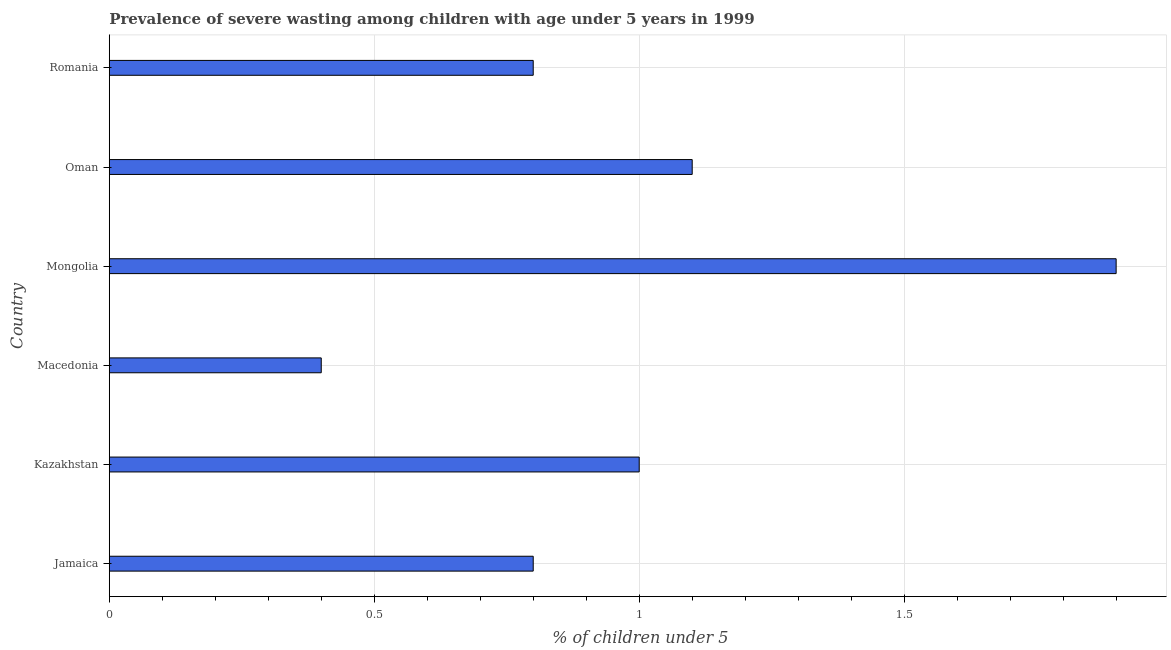Does the graph contain any zero values?
Give a very brief answer. No. What is the title of the graph?
Your response must be concise. Prevalence of severe wasting among children with age under 5 years in 1999. What is the label or title of the X-axis?
Provide a short and direct response.  % of children under 5. Across all countries, what is the maximum prevalence of severe wasting?
Your answer should be very brief. 1.9. Across all countries, what is the minimum prevalence of severe wasting?
Offer a terse response. 0.4. In which country was the prevalence of severe wasting maximum?
Ensure brevity in your answer.  Mongolia. In which country was the prevalence of severe wasting minimum?
Your answer should be compact. Macedonia. What is the sum of the prevalence of severe wasting?
Your answer should be very brief. 6. What is the difference between the prevalence of severe wasting in Jamaica and Mongolia?
Your answer should be very brief. -1.1. What is the median prevalence of severe wasting?
Provide a succinct answer. 0.9. What is the ratio of the prevalence of severe wasting in Jamaica to that in Romania?
Provide a short and direct response. 1. Is the prevalence of severe wasting in Oman less than that in Romania?
Your answer should be very brief. No. Is the difference between the prevalence of severe wasting in Mongolia and Oman greater than the difference between any two countries?
Offer a very short reply. No. What is the difference between the highest and the second highest prevalence of severe wasting?
Offer a terse response. 0.8. In how many countries, is the prevalence of severe wasting greater than the average prevalence of severe wasting taken over all countries?
Offer a terse response. 2. How many bars are there?
Make the answer very short. 6. Are all the bars in the graph horizontal?
Your answer should be very brief. Yes. How many countries are there in the graph?
Offer a very short reply. 6. What is the difference between two consecutive major ticks on the X-axis?
Offer a very short reply. 0.5. Are the values on the major ticks of X-axis written in scientific E-notation?
Make the answer very short. No. What is the  % of children under 5 of Jamaica?
Give a very brief answer. 0.8. What is the  % of children under 5 in Macedonia?
Provide a succinct answer. 0.4. What is the  % of children under 5 of Mongolia?
Keep it short and to the point. 1.9. What is the  % of children under 5 in Oman?
Keep it short and to the point. 1.1. What is the  % of children under 5 of Romania?
Make the answer very short. 0.8. What is the difference between the  % of children under 5 in Jamaica and Macedonia?
Give a very brief answer. 0.4. What is the difference between the  % of children under 5 in Kazakhstan and Macedonia?
Your response must be concise. 0.6. What is the difference between the  % of children under 5 in Kazakhstan and Mongolia?
Ensure brevity in your answer.  -0.9. What is the difference between the  % of children under 5 in Kazakhstan and Oman?
Your answer should be very brief. -0.1. What is the difference between the  % of children under 5 in Macedonia and Mongolia?
Give a very brief answer. -1.5. What is the difference between the  % of children under 5 in Macedonia and Oman?
Your answer should be compact. -0.7. What is the difference between the  % of children under 5 in Mongolia and Oman?
Provide a short and direct response. 0.8. What is the difference between the  % of children under 5 in Oman and Romania?
Offer a terse response. 0.3. What is the ratio of the  % of children under 5 in Jamaica to that in Macedonia?
Offer a very short reply. 2. What is the ratio of the  % of children under 5 in Jamaica to that in Mongolia?
Your response must be concise. 0.42. What is the ratio of the  % of children under 5 in Jamaica to that in Oman?
Provide a succinct answer. 0.73. What is the ratio of the  % of children under 5 in Kazakhstan to that in Macedonia?
Provide a short and direct response. 2.5. What is the ratio of the  % of children under 5 in Kazakhstan to that in Mongolia?
Ensure brevity in your answer.  0.53. What is the ratio of the  % of children under 5 in Kazakhstan to that in Oman?
Provide a succinct answer. 0.91. What is the ratio of the  % of children under 5 in Macedonia to that in Mongolia?
Provide a short and direct response. 0.21. What is the ratio of the  % of children under 5 in Macedonia to that in Oman?
Your response must be concise. 0.36. What is the ratio of the  % of children under 5 in Mongolia to that in Oman?
Make the answer very short. 1.73. What is the ratio of the  % of children under 5 in Mongolia to that in Romania?
Make the answer very short. 2.38. What is the ratio of the  % of children under 5 in Oman to that in Romania?
Provide a succinct answer. 1.38. 